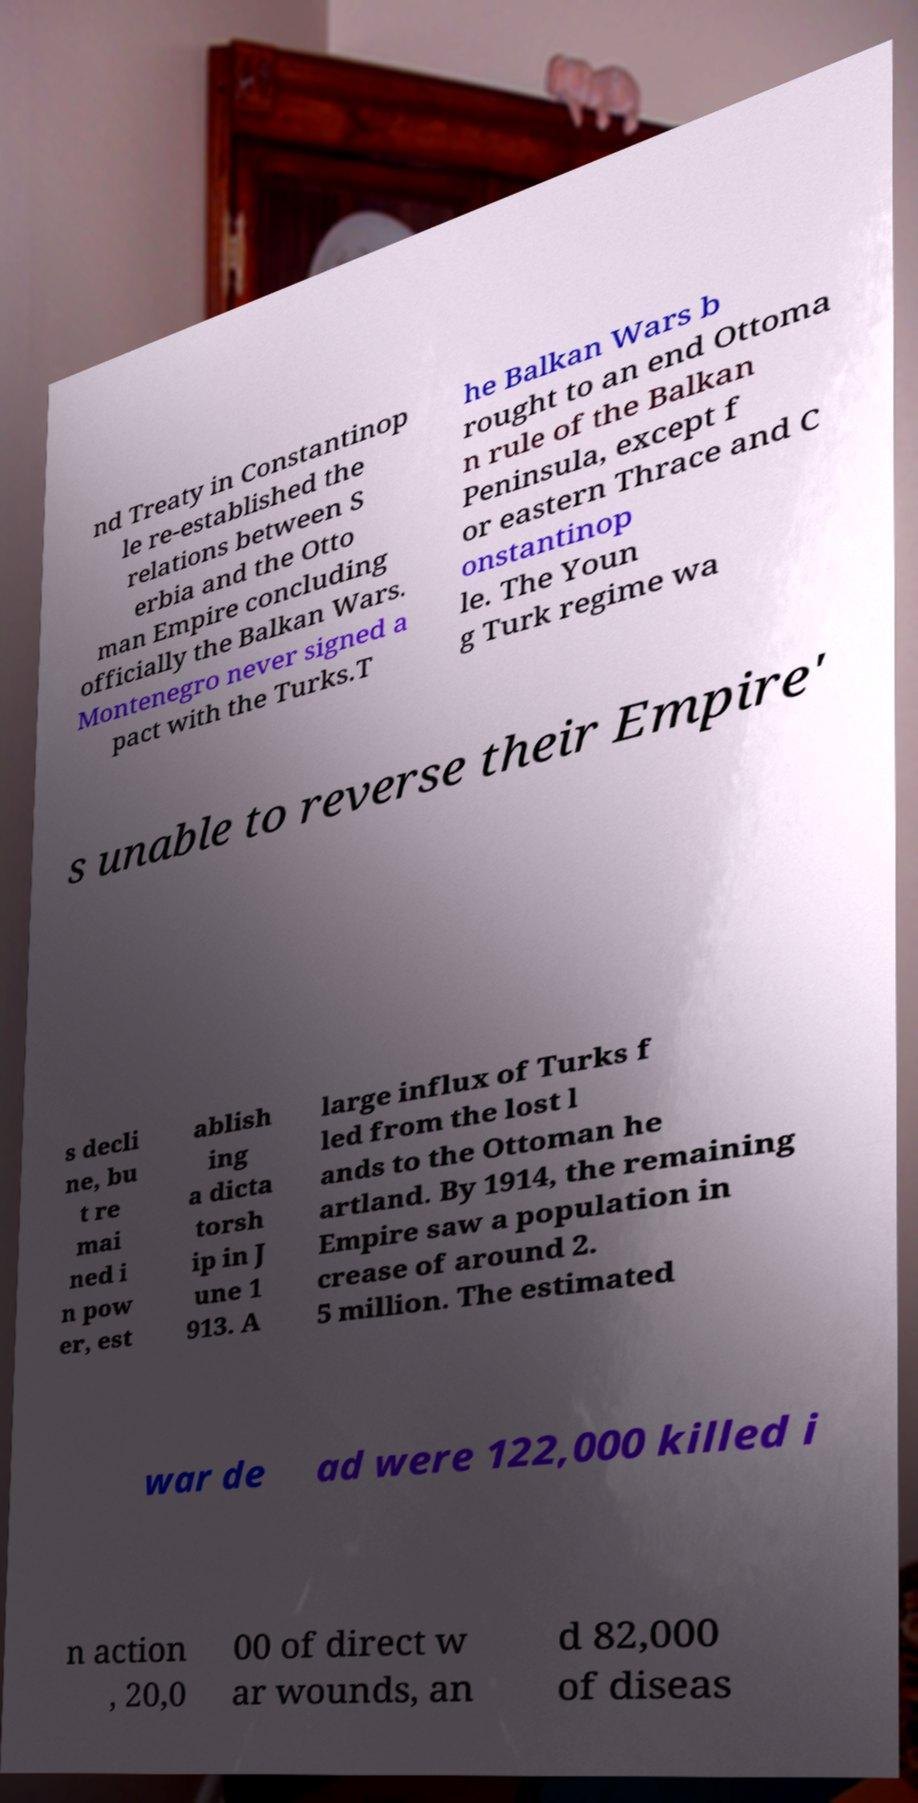Could you extract and type out the text from this image? nd Treaty in Constantinop le re-established the relations between S erbia and the Otto man Empire concluding officially the Balkan Wars. Montenegro never signed a pact with the Turks.T he Balkan Wars b rought to an end Ottoma n rule of the Balkan Peninsula, except f or eastern Thrace and C onstantinop le. The Youn g Turk regime wa s unable to reverse their Empire' s decli ne, bu t re mai ned i n pow er, est ablish ing a dicta torsh ip in J une 1 913. A large influx of Turks f led from the lost l ands to the Ottoman he artland. By 1914, the remaining Empire saw a population in crease of around 2. 5 million. The estimated war de ad were 122,000 killed i n action , 20,0 00 of direct w ar wounds, an d 82,000 of diseas 